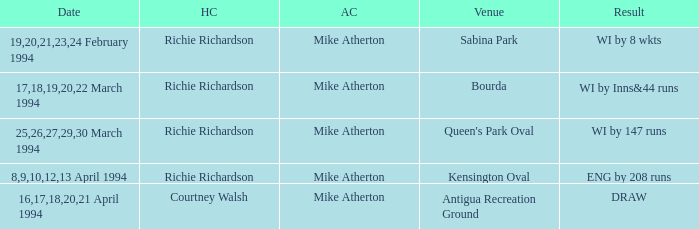Which Home Captain has Venue of Bourda? Richie Richardson. 